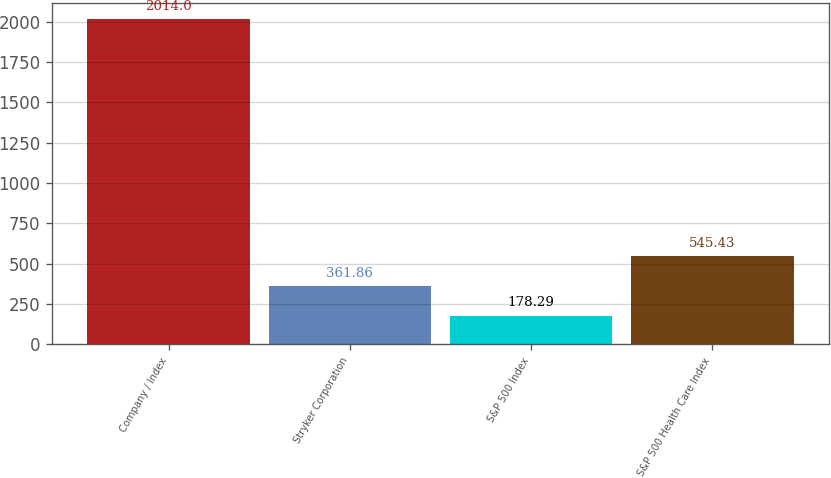<chart> <loc_0><loc_0><loc_500><loc_500><bar_chart><fcel>Company / Index<fcel>Stryker Corporation<fcel>S&P 500 Index<fcel>S&P 500 Health Care Index<nl><fcel>2014<fcel>361.86<fcel>178.29<fcel>545.43<nl></chart> 